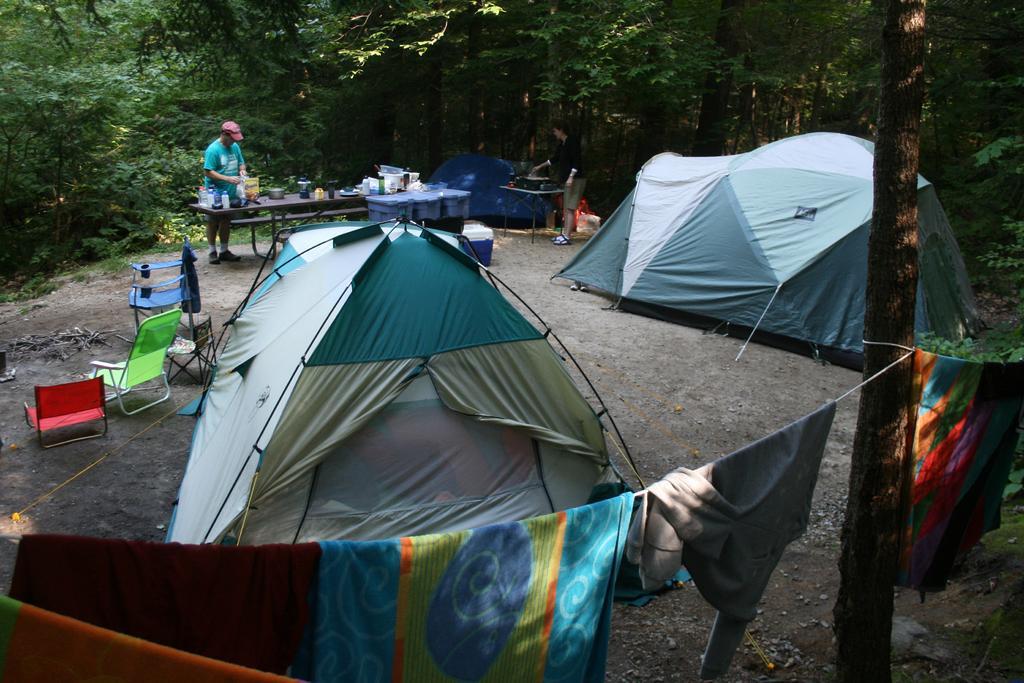Could you give a brief overview of what you see in this image? Here in this picture we can see tents and chairs and tables present on the ground over there and we can see a person standing near the table and we can see number of things on the table over there and in the front we can see clothes hanging on the wire, which is tied to the tree over there and we can see plants and trees present all over there. 